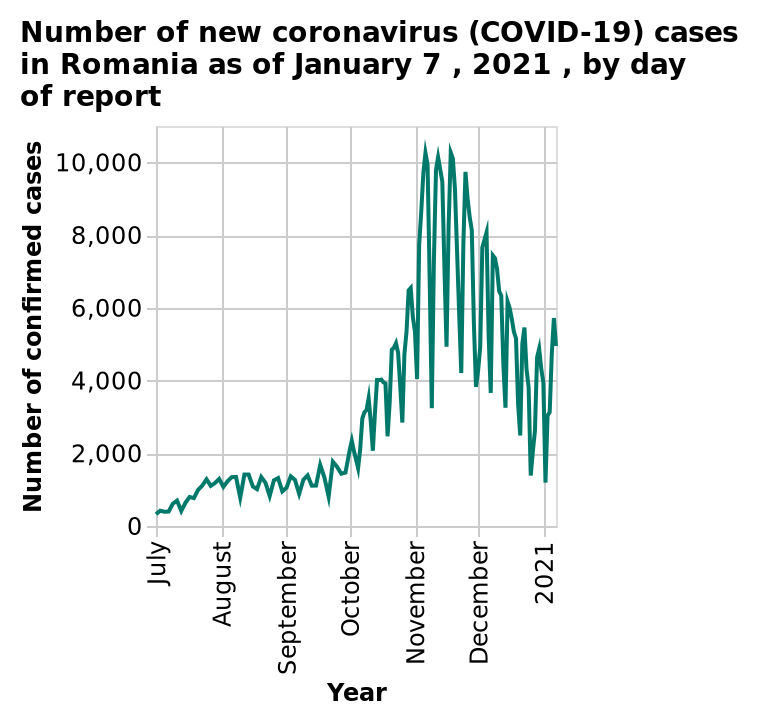<image>
What happened to coronavirus cases in Romania after November 2020? Coronavirus cases in Romania began to decrease after November 2020. 